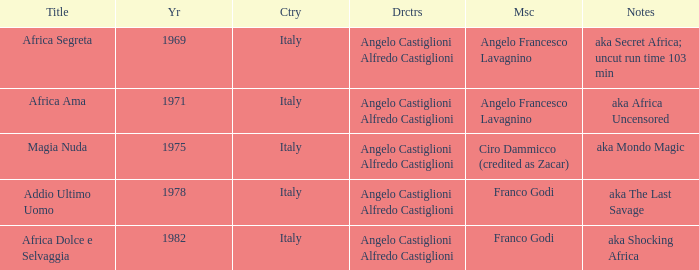Which music has the notes of AKA Africa Uncensored? Angelo Francesco Lavagnino. 